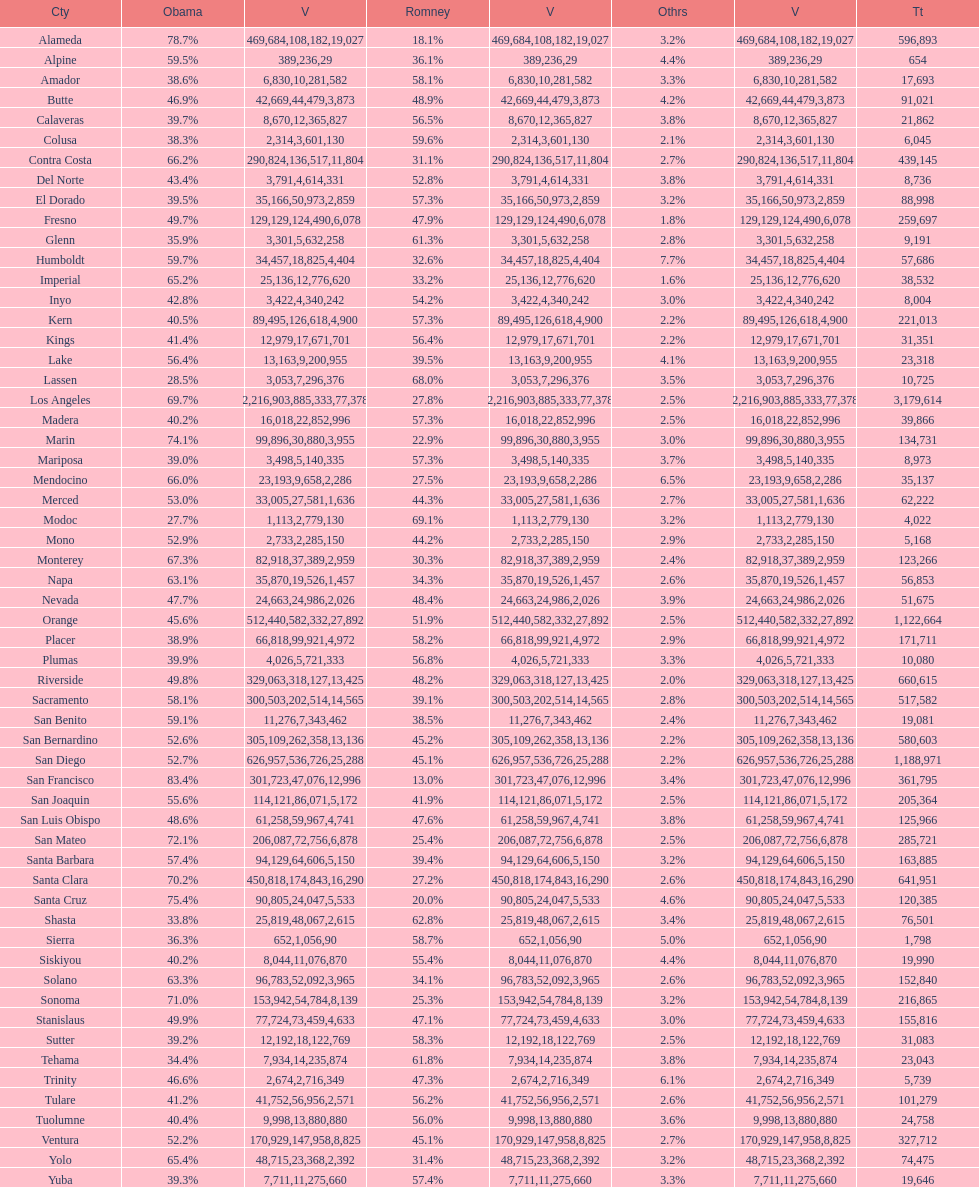Which count had the least number of votes for obama? Modoc. 